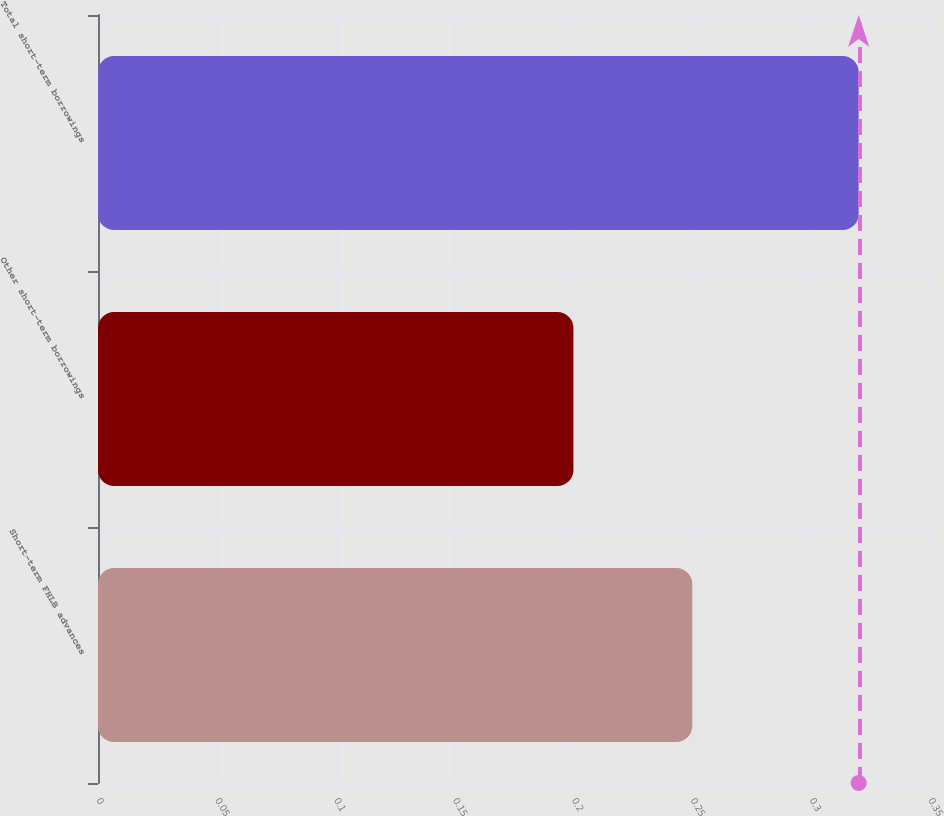Convert chart. <chart><loc_0><loc_0><loc_500><loc_500><bar_chart><fcel>Short-term FHLB advances<fcel>Other short-term borrowings<fcel>Total short-term borrowings<nl><fcel>0.25<fcel>0.2<fcel>0.32<nl></chart> 